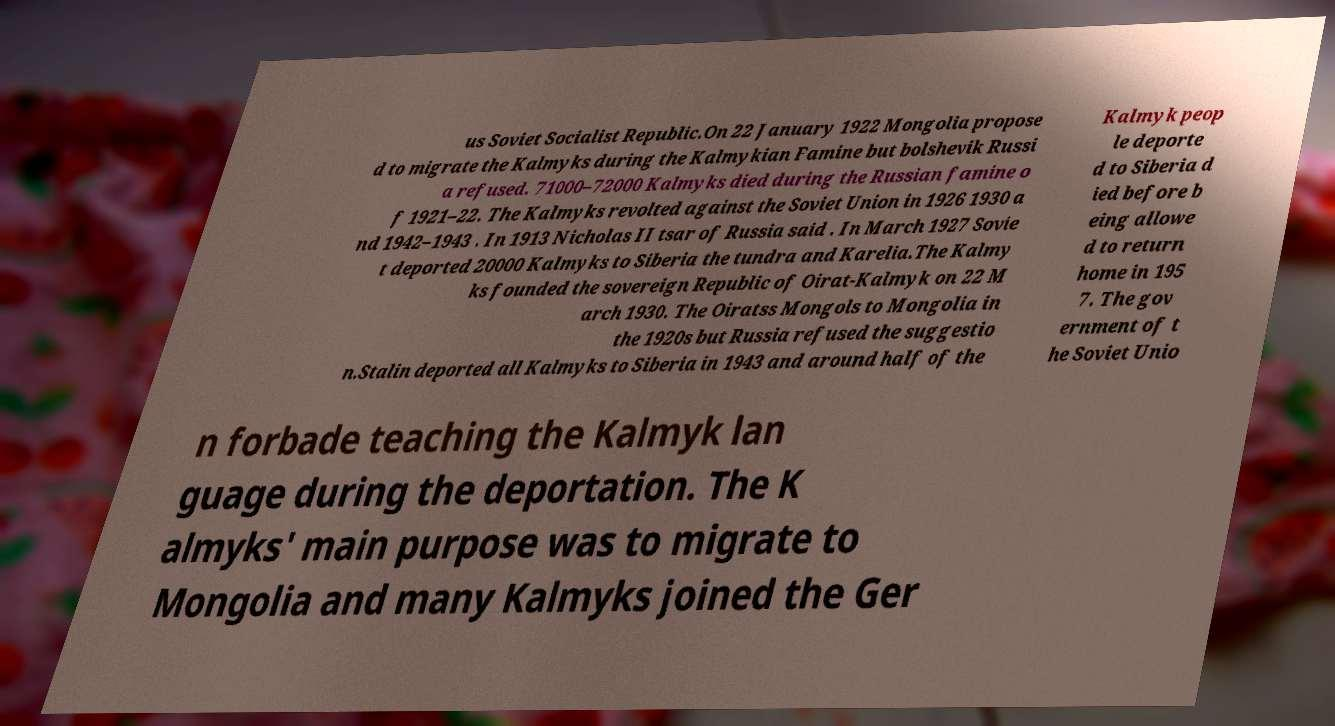Can you accurately transcribe the text from the provided image for me? us Soviet Socialist Republic.On 22 January 1922 Mongolia propose d to migrate the Kalmyks during the Kalmykian Famine but bolshevik Russi a refused. 71000–72000 Kalmyks died during the Russian famine o f 1921–22. The Kalmyks revolted against the Soviet Union in 1926 1930 a nd 1942–1943 . In 1913 Nicholas II tsar of Russia said . In March 1927 Sovie t deported 20000 Kalmyks to Siberia the tundra and Karelia.The Kalmy ks founded the sovereign Republic of Oirat-Kalmyk on 22 M arch 1930. The Oiratss Mongols to Mongolia in the 1920s but Russia refused the suggestio n.Stalin deported all Kalmyks to Siberia in 1943 and around half of the Kalmyk peop le deporte d to Siberia d ied before b eing allowe d to return home in 195 7. The gov ernment of t he Soviet Unio n forbade teaching the Kalmyk lan guage during the deportation. The K almyks' main purpose was to migrate to Mongolia and many Kalmyks joined the Ger 